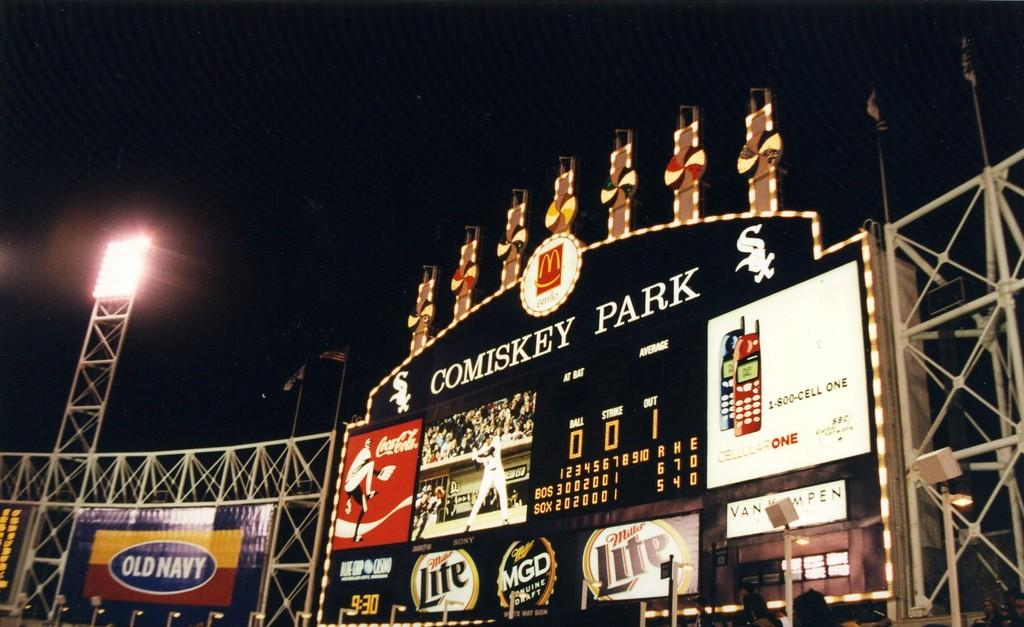<image>
Give a short and clear explanation of the subsequent image. Score board in Comiskey Park showing the score and an ad for Old Navy. 